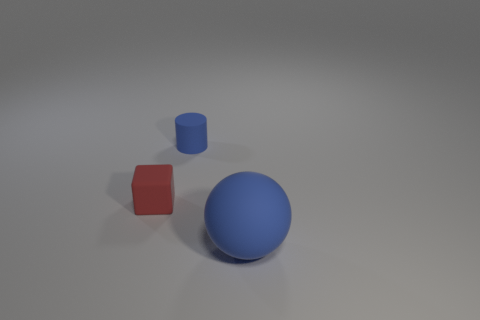The rubber object that is the same color as the big sphere is what size?
Your response must be concise. Small. There is a blue object that is to the left of the blue rubber object to the right of the blue matte object that is on the left side of the big blue sphere; what is its size?
Your answer should be compact. Small. Do the blue object behind the tiny cube and the blue thing that is in front of the red object have the same material?
Offer a very short reply. Yes. How many other things are the same color as the matte sphere?
Give a very brief answer. 1. What number of things are either small objects behind the small red rubber thing or blue matte things that are in front of the red matte cube?
Provide a succinct answer. 2. How big is the object that is on the left side of the tiny cylinder that is right of the small cube?
Give a very brief answer. Small. The red block is what size?
Keep it short and to the point. Small. Do the matte thing on the right side of the small rubber cylinder and the matte object that is behind the red object have the same color?
Your answer should be very brief. Yes. How many other things are there of the same material as the large blue thing?
Your answer should be very brief. 2. Is there a red rubber object?
Your response must be concise. Yes. 